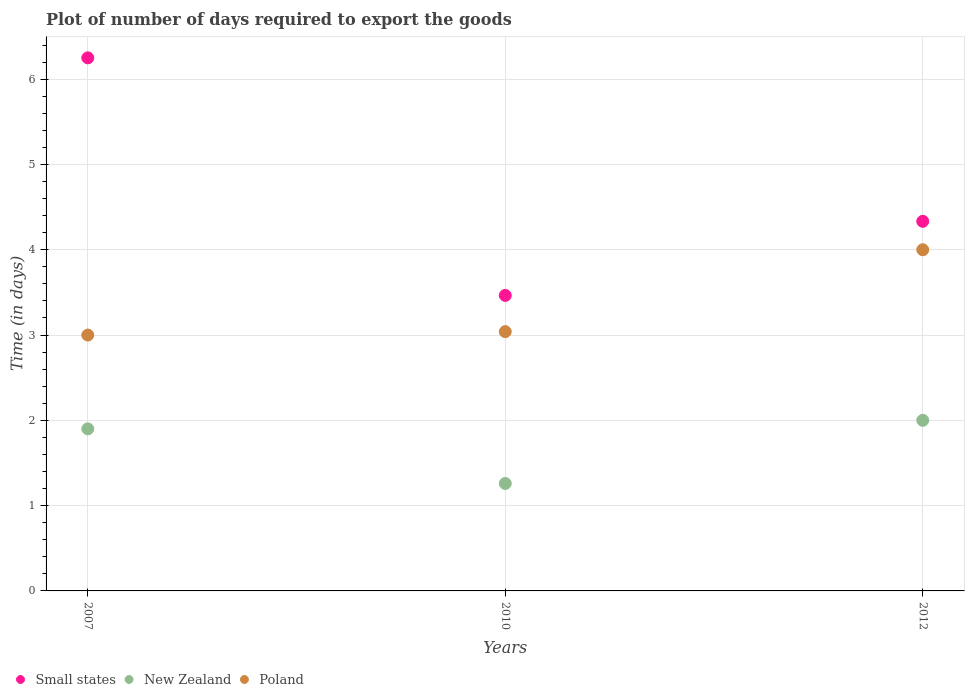How many different coloured dotlines are there?
Your response must be concise. 3. What is the time required to export goods in Small states in 2012?
Make the answer very short. 4.33. Across all years, what is the maximum time required to export goods in Small states?
Offer a terse response. 6.25. In which year was the time required to export goods in Poland maximum?
Offer a very short reply. 2012. What is the total time required to export goods in Small states in the graph?
Your answer should be very brief. 14.05. What is the difference between the time required to export goods in Poland in 2007 and that in 2010?
Provide a short and direct response. -0.04. What is the difference between the time required to export goods in New Zealand in 2012 and the time required to export goods in Poland in 2007?
Provide a succinct answer. -1. What is the average time required to export goods in New Zealand per year?
Offer a terse response. 1.72. In the year 2010, what is the difference between the time required to export goods in New Zealand and time required to export goods in Poland?
Keep it short and to the point. -1.78. In how many years, is the time required to export goods in New Zealand greater than 2.6 days?
Provide a succinct answer. 0. What is the ratio of the time required to export goods in New Zealand in 2007 to that in 2010?
Ensure brevity in your answer.  1.51. Is the time required to export goods in Poland in 2007 less than that in 2010?
Provide a succinct answer. Yes. Is the difference between the time required to export goods in New Zealand in 2010 and 2012 greater than the difference between the time required to export goods in Poland in 2010 and 2012?
Your answer should be compact. Yes. What is the difference between the highest and the second highest time required to export goods in Poland?
Your answer should be very brief. 0.96. What is the difference between the highest and the lowest time required to export goods in New Zealand?
Keep it short and to the point. 0.74. Is the sum of the time required to export goods in Small states in 2010 and 2012 greater than the maximum time required to export goods in New Zealand across all years?
Keep it short and to the point. Yes. Is it the case that in every year, the sum of the time required to export goods in New Zealand and time required to export goods in Small states  is greater than the time required to export goods in Poland?
Your answer should be compact. Yes. Does the time required to export goods in Small states monotonically increase over the years?
Offer a very short reply. No. Is the time required to export goods in Poland strictly less than the time required to export goods in New Zealand over the years?
Your response must be concise. No. How many dotlines are there?
Ensure brevity in your answer.  3. What is the difference between two consecutive major ticks on the Y-axis?
Keep it short and to the point. 1. Does the graph contain any zero values?
Your answer should be very brief. No. Does the graph contain grids?
Give a very brief answer. Yes. What is the title of the graph?
Provide a short and direct response. Plot of number of days required to export the goods. Does "Bahrain" appear as one of the legend labels in the graph?
Offer a very short reply. No. What is the label or title of the X-axis?
Your response must be concise. Years. What is the label or title of the Y-axis?
Provide a short and direct response. Time (in days). What is the Time (in days) in Small states in 2007?
Your answer should be compact. 6.25. What is the Time (in days) of Small states in 2010?
Make the answer very short. 3.46. What is the Time (in days) of New Zealand in 2010?
Offer a very short reply. 1.26. What is the Time (in days) of Poland in 2010?
Ensure brevity in your answer.  3.04. What is the Time (in days) in Small states in 2012?
Your response must be concise. 4.33. Across all years, what is the maximum Time (in days) in Small states?
Keep it short and to the point. 6.25. Across all years, what is the maximum Time (in days) of Poland?
Provide a succinct answer. 4. Across all years, what is the minimum Time (in days) in Small states?
Make the answer very short. 3.46. Across all years, what is the minimum Time (in days) of New Zealand?
Your response must be concise. 1.26. What is the total Time (in days) of Small states in the graph?
Provide a succinct answer. 14.05. What is the total Time (in days) in New Zealand in the graph?
Offer a terse response. 5.16. What is the total Time (in days) in Poland in the graph?
Offer a terse response. 10.04. What is the difference between the Time (in days) of Small states in 2007 and that in 2010?
Make the answer very short. 2.79. What is the difference between the Time (in days) of New Zealand in 2007 and that in 2010?
Offer a terse response. 0.64. What is the difference between the Time (in days) of Poland in 2007 and that in 2010?
Your answer should be very brief. -0.04. What is the difference between the Time (in days) in Small states in 2007 and that in 2012?
Keep it short and to the point. 1.92. What is the difference between the Time (in days) of Small states in 2010 and that in 2012?
Your response must be concise. -0.87. What is the difference between the Time (in days) of New Zealand in 2010 and that in 2012?
Your response must be concise. -0.74. What is the difference between the Time (in days) of Poland in 2010 and that in 2012?
Your response must be concise. -0.96. What is the difference between the Time (in days) of Small states in 2007 and the Time (in days) of New Zealand in 2010?
Offer a terse response. 4.99. What is the difference between the Time (in days) of Small states in 2007 and the Time (in days) of Poland in 2010?
Your response must be concise. 3.21. What is the difference between the Time (in days) in New Zealand in 2007 and the Time (in days) in Poland in 2010?
Offer a terse response. -1.14. What is the difference between the Time (in days) in Small states in 2007 and the Time (in days) in New Zealand in 2012?
Ensure brevity in your answer.  4.25. What is the difference between the Time (in days) in Small states in 2007 and the Time (in days) in Poland in 2012?
Offer a terse response. 2.25. What is the difference between the Time (in days) of New Zealand in 2007 and the Time (in days) of Poland in 2012?
Your response must be concise. -2.1. What is the difference between the Time (in days) in Small states in 2010 and the Time (in days) in New Zealand in 2012?
Keep it short and to the point. 1.47. What is the difference between the Time (in days) in Small states in 2010 and the Time (in days) in Poland in 2012?
Ensure brevity in your answer.  -0.54. What is the difference between the Time (in days) in New Zealand in 2010 and the Time (in days) in Poland in 2012?
Make the answer very short. -2.74. What is the average Time (in days) of Small states per year?
Provide a short and direct response. 4.68. What is the average Time (in days) in New Zealand per year?
Offer a very short reply. 1.72. What is the average Time (in days) of Poland per year?
Ensure brevity in your answer.  3.35. In the year 2007, what is the difference between the Time (in days) of Small states and Time (in days) of New Zealand?
Your response must be concise. 4.35. In the year 2007, what is the difference between the Time (in days) of New Zealand and Time (in days) of Poland?
Ensure brevity in your answer.  -1.1. In the year 2010, what is the difference between the Time (in days) in Small states and Time (in days) in New Zealand?
Offer a terse response. 2.21. In the year 2010, what is the difference between the Time (in days) of Small states and Time (in days) of Poland?
Ensure brevity in your answer.  0.42. In the year 2010, what is the difference between the Time (in days) of New Zealand and Time (in days) of Poland?
Make the answer very short. -1.78. In the year 2012, what is the difference between the Time (in days) in Small states and Time (in days) in New Zealand?
Your response must be concise. 2.33. In the year 2012, what is the difference between the Time (in days) in Small states and Time (in days) in Poland?
Offer a very short reply. 0.33. In the year 2012, what is the difference between the Time (in days) in New Zealand and Time (in days) in Poland?
Provide a short and direct response. -2. What is the ratio of the Time (in days) of Small states in 2007 to that in 2010?
Provide a short and direct response. 1.8. What is the ratio of the Time (in days) in New Zealand in 2007 to that in 2010?
Provide a succinct answer. 1.51. What is the ratio of the Time (in days) in Small states in 2007 to that in 2012?
Keep it short and to the point. 1.44. What is the ratio of the Time (in days) in Small states in 2010 to that in 2012?
Offer a terse response. 0.8. What is the ratio of the Time (in days) of New Zealand in 2010 to that in 2012?
Ensure brevity in your answer.  0.63. What is the ratio of the Time (in days) in Poland in 2010 to that in 2012?
Offer a very short reply. 0.76. What is the difference between the highest and the second highest Time (in days) of Small states?
Your answer should be very brief. 1.92. What is the difference between the highest and the second highest Time (in days) in New Zealand?
Give a very brief answer. 0.1. What is the difference between the highest and the second highest Time (in days) of Poland?
Ensure brevity in your answer.  0.96. What is the difference between the highest and the lowest Time (in days) of Small states?
Make the answer very short. 2.79. What is the difference between the highest and the lowest Time (in days) in New Zealand?
Give a very brief answer. 0.74. What is the difference between the highest and the lowest Time (in days) in Poland?
Keep it short and to the point. 1. 